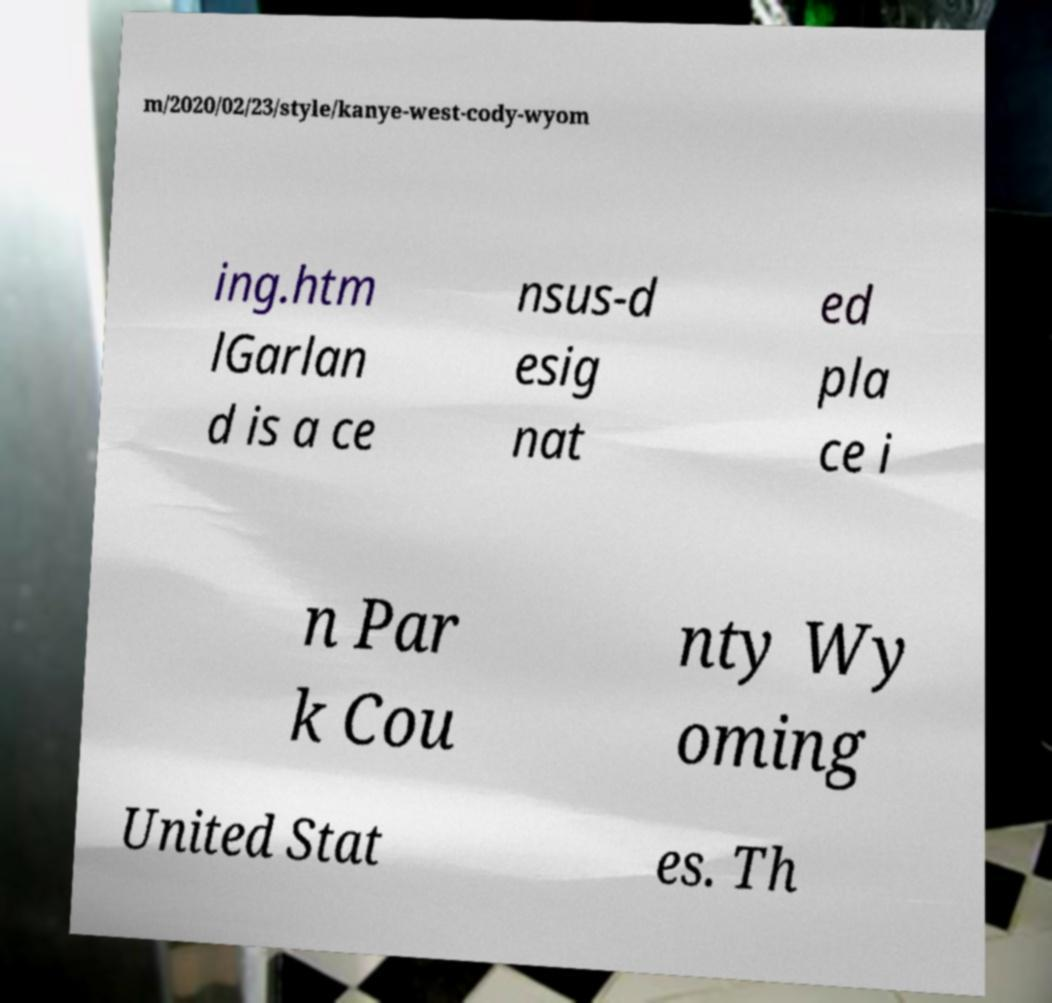There's text embedded in this image that I need extracted. Can you transcribe it verbatim? m/2020/02/23/style/kanye-west-cody-wyom ing.htm lGarlan d is a ce nsus-d esig nat ed pla ce i n Par k Cou nty Wy oming United Stat es. Th 